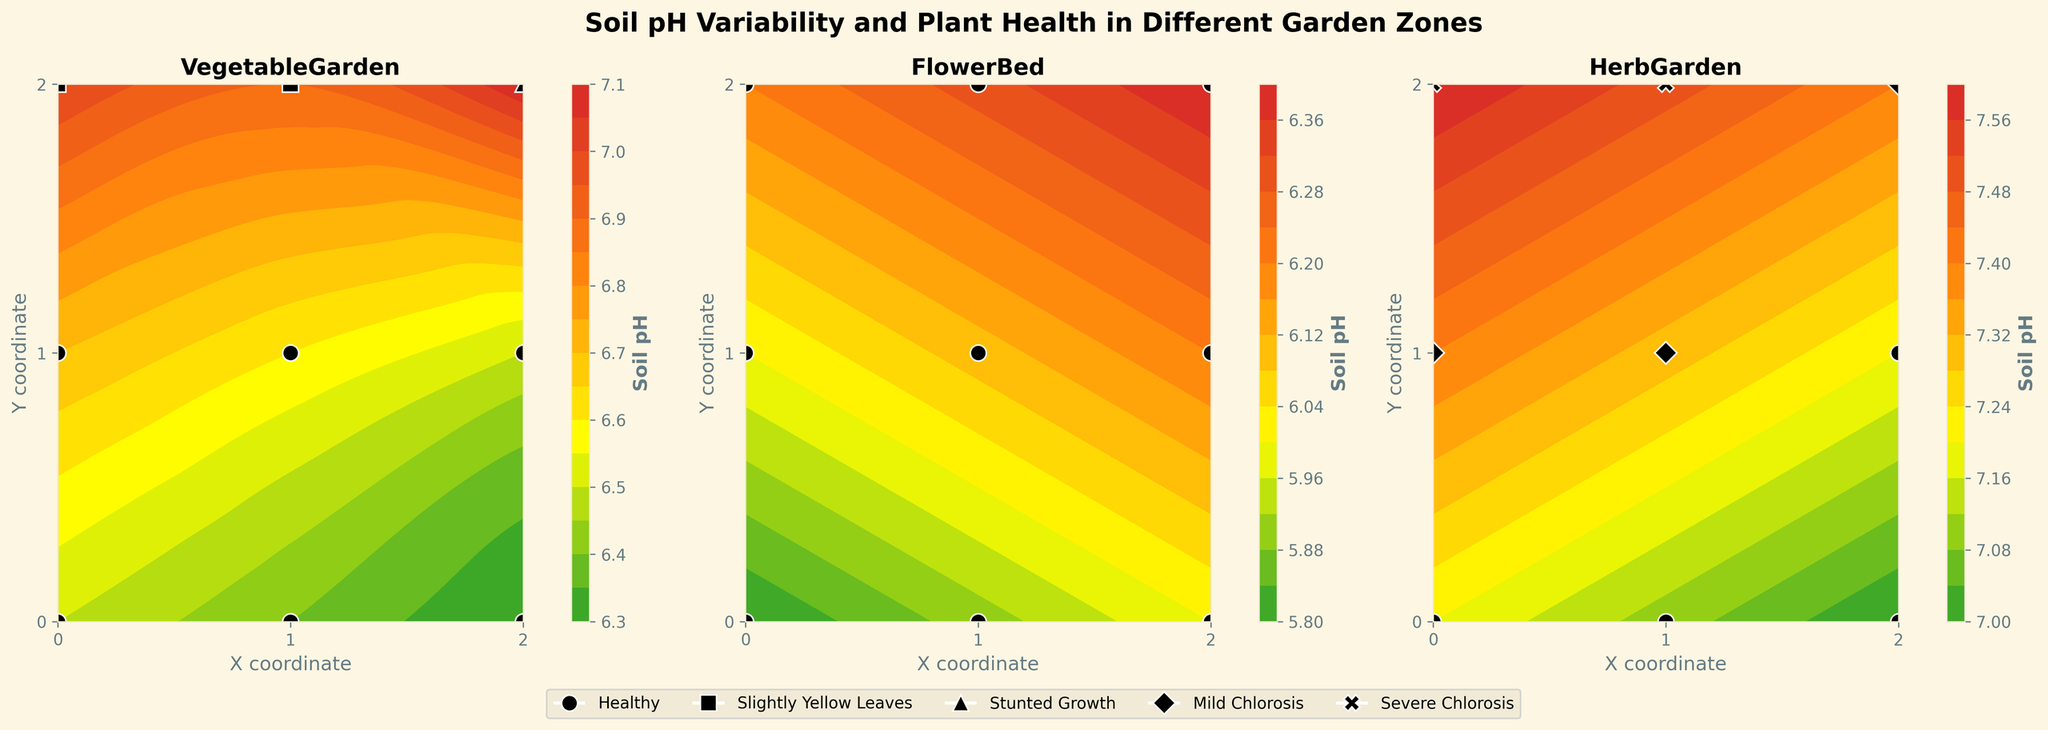What is the title of the figure? The title is displayed prominently at the top of the figure in bold font.
Answer: Soil pH Variability and Plant Health in Different Garden Zones How many garden zones are analyzed in the figure? The figure contains three subplots, each labeled with a different garden zone.
Answer: 3 What pH is associated with 'Stunted Growth' in the VegetableGarden zone? In the subplot for VegetableGarden, the black marker with a triangle (^) denotes 'Stunted Growth' and is located at pH ~7.1.
Answer: 7.1 What garden zone shows the most severe plant health issue? Check for the 'X' markers which denote 'Severe Chlorosis' in the subplots. The HerbGarden zone shows these markers.
Answer: HerbGarden Compare the pH levels between the VegetableGarden and FlowerBed zones. Which zone has more variability? Examine the contour colors and range of pH values in both subplots. The VegetableGarden shows a wider range of colors, indicating more pH variability.
Answer: VegetableGarden Which garden zone has the overall healthiest plants? Look for the 'o' markers that indicate 'Healthy' plants. The FlowerBed zone has only 'Healthy' markers.
Answer: FlowerBed In the HerbGarden, what is the plant health at the highest pH location? Find the subplot for HerbGarden, locate the highest pH on the contour (approximately 7.6), and observe the black marker which is 'X'.
Answer: Severe Chlorosis What are the coordinate ranges used in each subplot? Each subplot shows coordinates ranging from 0 to 2 on both the x and y-axes. This can be seen by checking the axis labels and ticks.
Answer: 0 to 2 (X and Y) Identify the soil pH level range depicted in the FlowerBed subplot. Observe the contour color range in the FlowerBed subplot to determine the pH levels shown, which appear to be between 5.8 and 6.4.
Answer: 5.8 to 6.4 